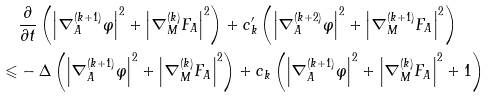Convert formula to latex. <formula><loc_0><loc_0><loc_500><loc_500>& \frac { \partial } { \partial t } \left ( { \left | { \nabla _ { A } ^ { ( k + 1 ) } \varphi } \right | ^ { 2 } + \left | { \nabla _ { M } ^ { ( k ) } F _ { A } } \right | ^ { 2 } } \right ) + c ^ { \prime } _ { k } \left ( { \left | { \nabla _ { A } ^ { ( k + 2 ) } \varphi } \right | ^ { 2 } + \left | { \nabla _ { M } ^ { ( k + 1 ) } F _ { A } } \right | ^ { 2 } } \right ) \\ \leqslant & - \Delta \left ( { \left | { \nabla _ { A } ^ { ( k + 1 ) } \varphi } \right | ^ { 2 } + \left | { \nabla _ { M } ^ { ( k ) } F _ { A } } \right | ^ { 2 } } \right ) + c _ { k } \left ( { \left | { \nabla _ { A } ^ { ( k + 1 ) } \varphi } \right | ^ { 2 } + \left | { \nabla _ { M } ^ { ( k ) } F _ { A } } \right | ^ { 2 } + 1 } \right )</formula> 